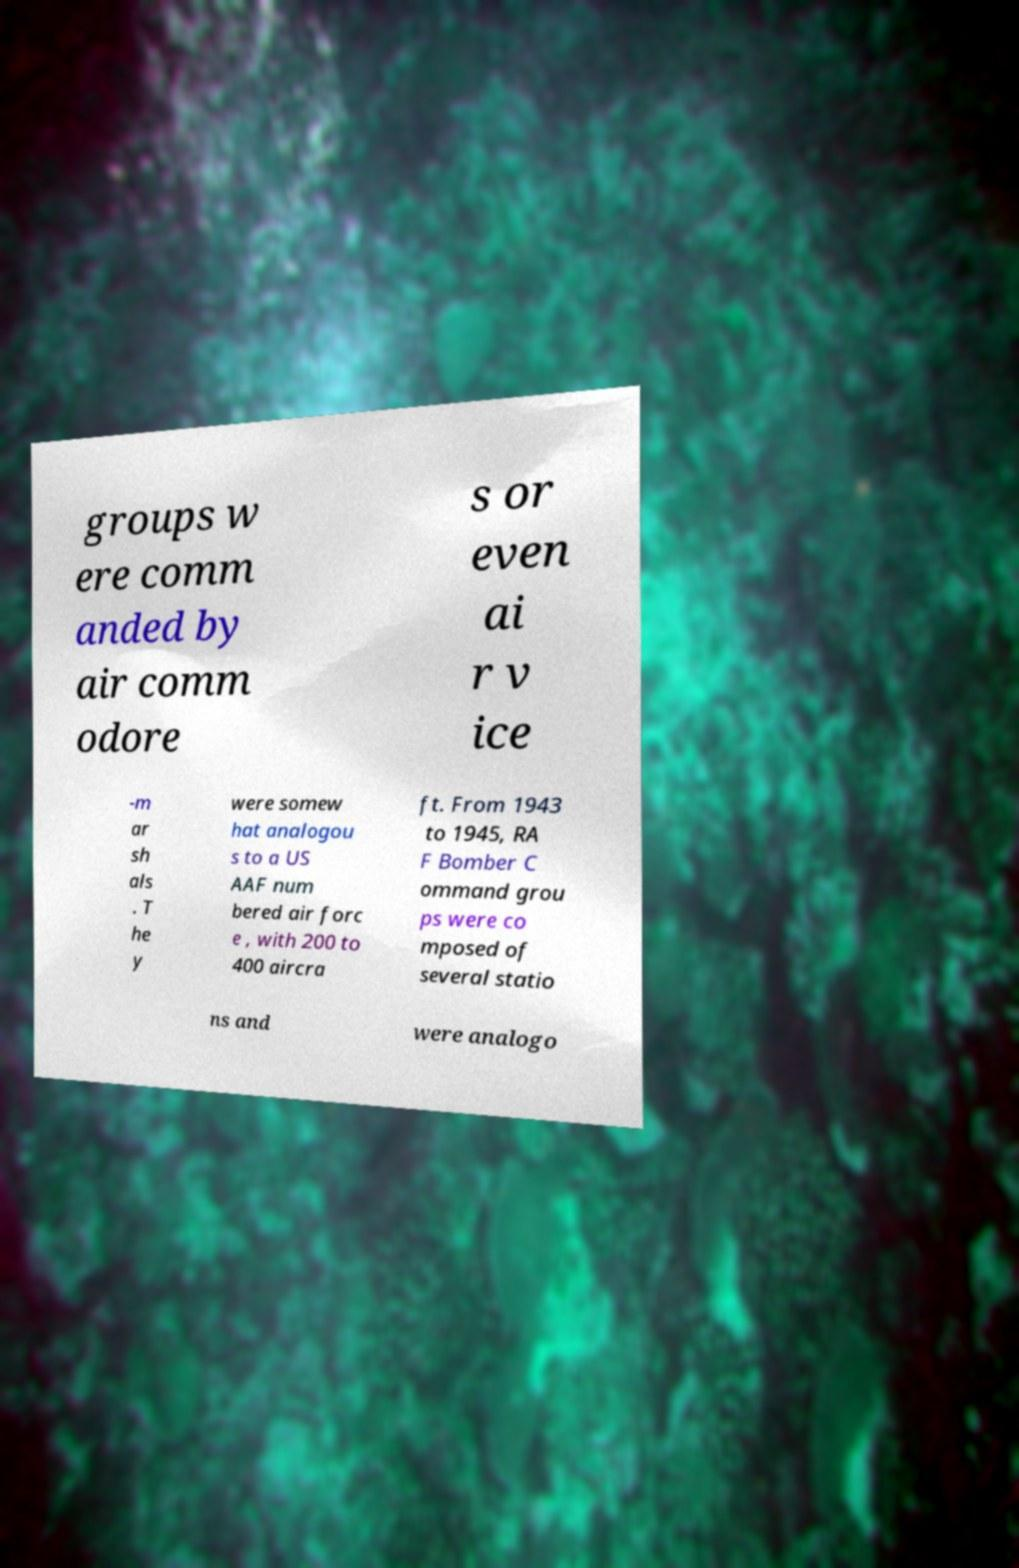What messages or text are displayed in this image? I need them in a readable, typed format. groups w ere comm anded by air comm odore s or even ai r v ice -m ar sh als . T he y were somew hat analogou s to a US AAF num bered air forc e , with 200 to 400 aircra ft. From 1943 to 1945, RA F Bomber C ommand grou ps were co mposed of several statio ns and were analogo 